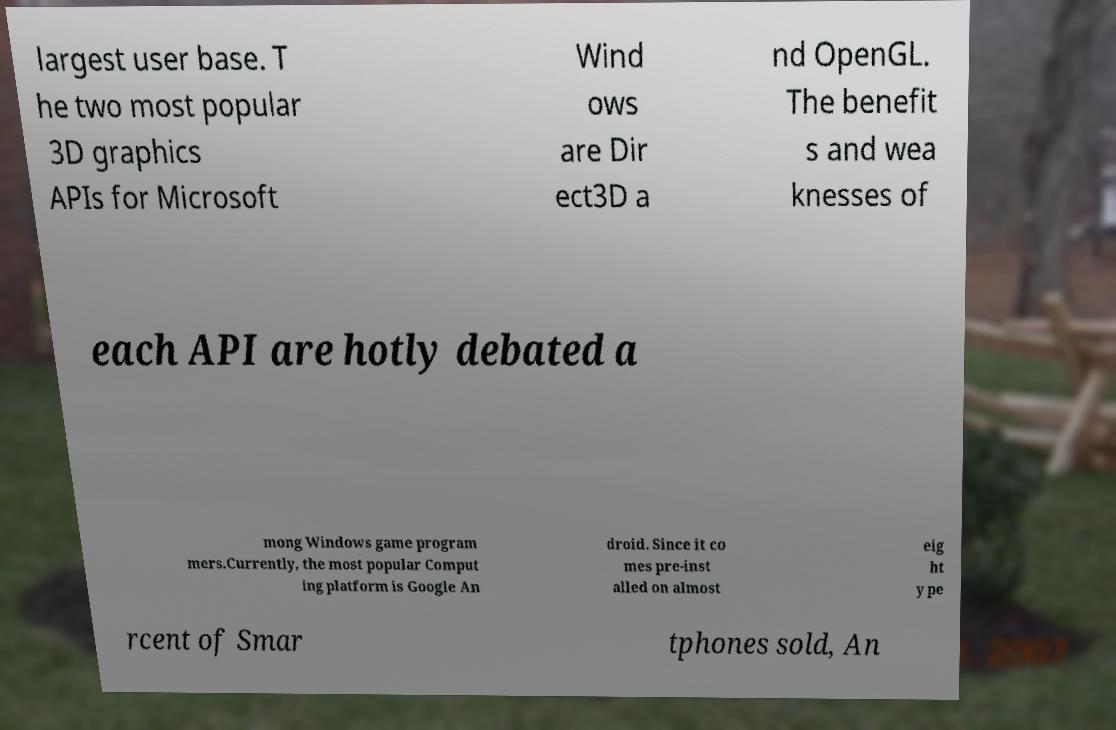Could you assist in decoding the text presented in this image and type it out clearly? largest user base. T he two most popular 3D graphics APIs for Microsoft Wind ows are Dir ect3D a nd OpenGL. The benefit s and wea knesses of each API are hotly debated a mong Windows game program mers.Currently, the most popular Comput ing platform is Google An droid. Since it co mes pre-inst alled on almost eig ht y pe rcent of Smar tphones sold, An 